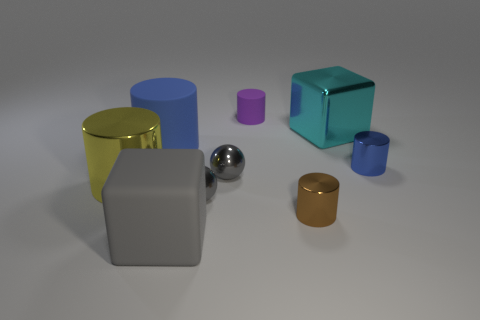Subtract 2 cylinders. How many cylinders are left? 3 Subtract all purple cylinders. How many cylinders are left? 4 Subtract all tiny blue cylinders. How many cylinders are left? 4 Subtract all cyan cylinders. Subtract all purple cubes. How many cylinders are left? 5 Add 1 small blue things. How many objects exist? 10 Subtract all blocks. How many objects are left? 7 Subtract 2 gray balls. How many objects are left? 7 Subtract all gray matte blocks. Subtract all matte cylinders. How many objects are left? 6 Add 8 tiny brown cylinders. How many tiny brown cylinders are left? 9 Add 7 purple cylinders. How many purple cylinders exist? 8 